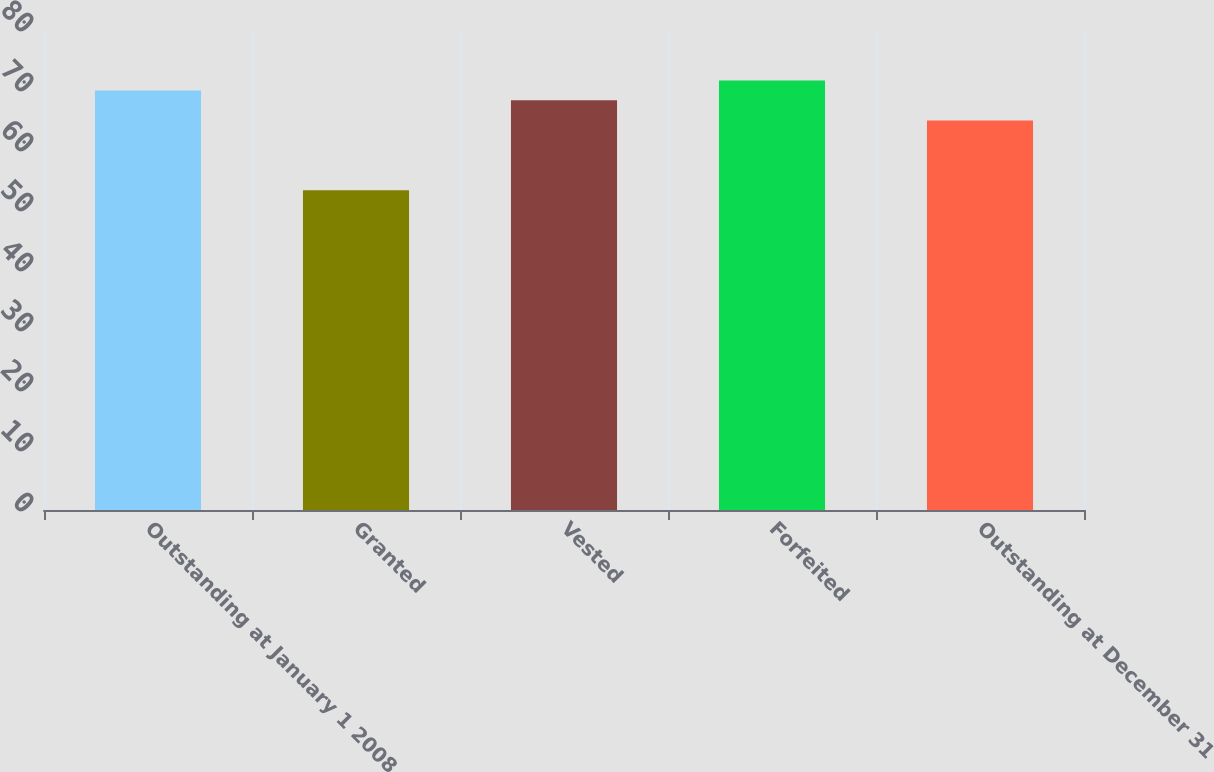Convert chart. <chart><loc_0><loc_0><loc_500><loc_500><bar_chart><fcel>Outstanding at January 1 2008<fcel>Granted<fcel>Vested<fcel>Forfeited<fcel>Outstanding at December 31<nl><fcel>69.93<fcel>53.29<fcel>68.29<fcel>71.57<fcel>64.93<nl></chart> 